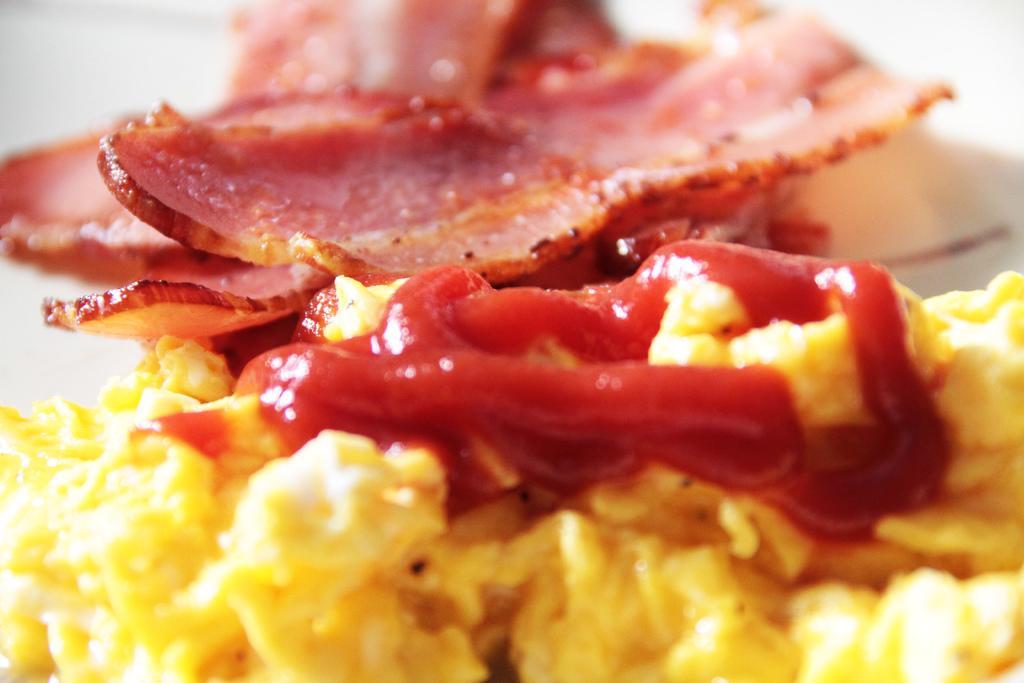In one or two sentences, can you explain what this image depicts? In the picture we can see some food item. 